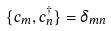Convert formula to latex. <formula><loc_0><loc_0><loc_500><loc_500>\{ c _ { m } , c _ { n } ^ { \dagger } \} = \delta _ { m n }</formula> 